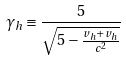Convert formula to latex. <formula><loc_0><loc_0><loc_500><loc_500>\gamma _ { h } \equiv \frac { 5 } { \sqrt { 5 - \frac { v _ { h } + v _ { h } } { c ^ { 2 } } } }</formula> 